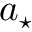<formula> <loc_0><loc_0><loc_500><loc_500>a _ { ^ { * } }</formula> 